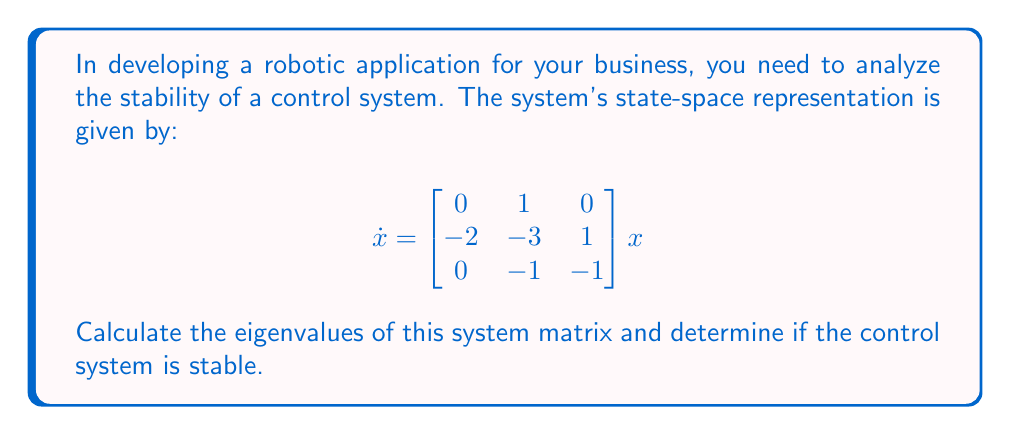Provide a solution to this math problem. To analyze the stability of this control system, we need to calculate the eigenvalues of the system matrix. A system is stable if all eigenvalues have negative real parts.

Step 1: Set up the characteristic equation:
$$det(\lambda I - A) = 0$$

Where $I$ is the 3x3 identity matrix and $A$ is the given system matrix.

Step 2: Expand the determinant:
$$\begin{vmatrix} 
\lambda & -1 & 0 \\
2 & \lambda+3 & -1 \\
0 & 1 & \lambda+1
\end{vmatrix} = 0$$

Step 3: Calculate the determinant:
$$\lambda(\lambda+3)(\lambda+1) + 0 + 0 - (0 + \lambda + 2(\lambda+1)) = 0$$
$$\lambda^3 + 4\lambda^2 + 3\lambda + (\lambda + 2) = 0$$
$$\lambda^3 + 4\lambda^2 + 4\lambda + 2 = 0$$

Step 4: Solve the cubic equation. This can be done using the cubic formula or numerical methods. Using a numerical solver, we find the roots:

$$\lambda_1 \approx -2.769$$
$$\lambda_2 \approx -0.615 + 0.780i$$
$$\lambda_3 \approx -0.615 - 0.780i$$

Step 5: Analyze the eigenvalues:
All three eigenvalues have negative real parts. Therefore, the system is stable.
Answer: The eigenvalues are approximately $-2.769$, $-0.615 + 0.780i$, and $-0.615 - 0.780i$. Since all eigenvalues have negative real parts, the control system is stable. 